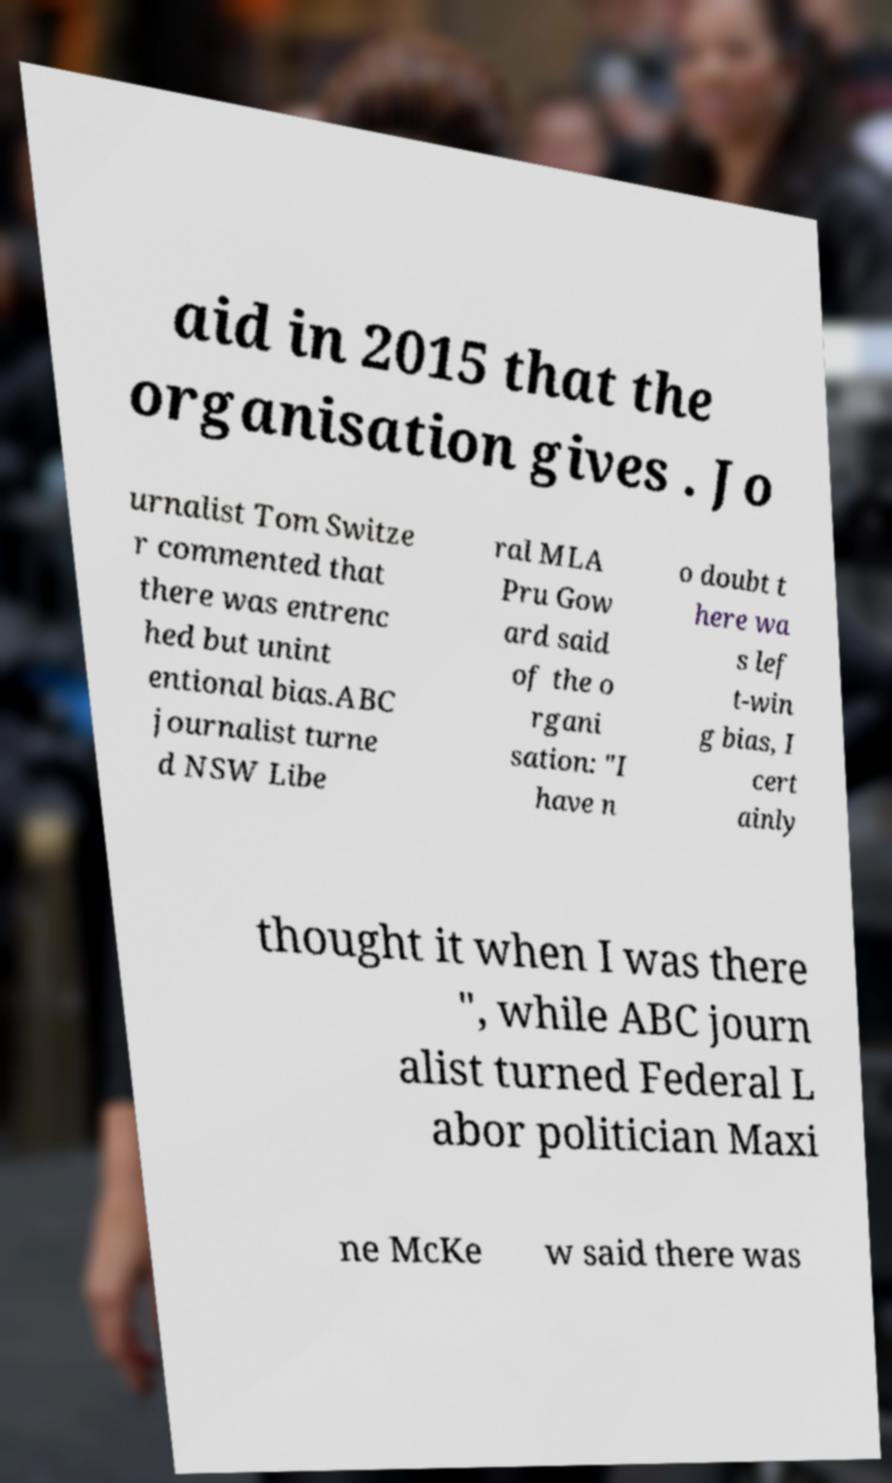Could you extract and type out the text from this image? aid in 2015 that the organisation gives . Jo urnalist Tom Switze r commented that there was entrenc hed but unint entional bias.ABC journalist turne d NSW Libe ral MLA Pru Gow ard said of the o rgani sation: "I have n o doubt t here wa s lef t-win g bias, I cert ainly thought it when I was there ", while ABC journ alist turned Federal L abor politician Maxi ne McKe w said there was 